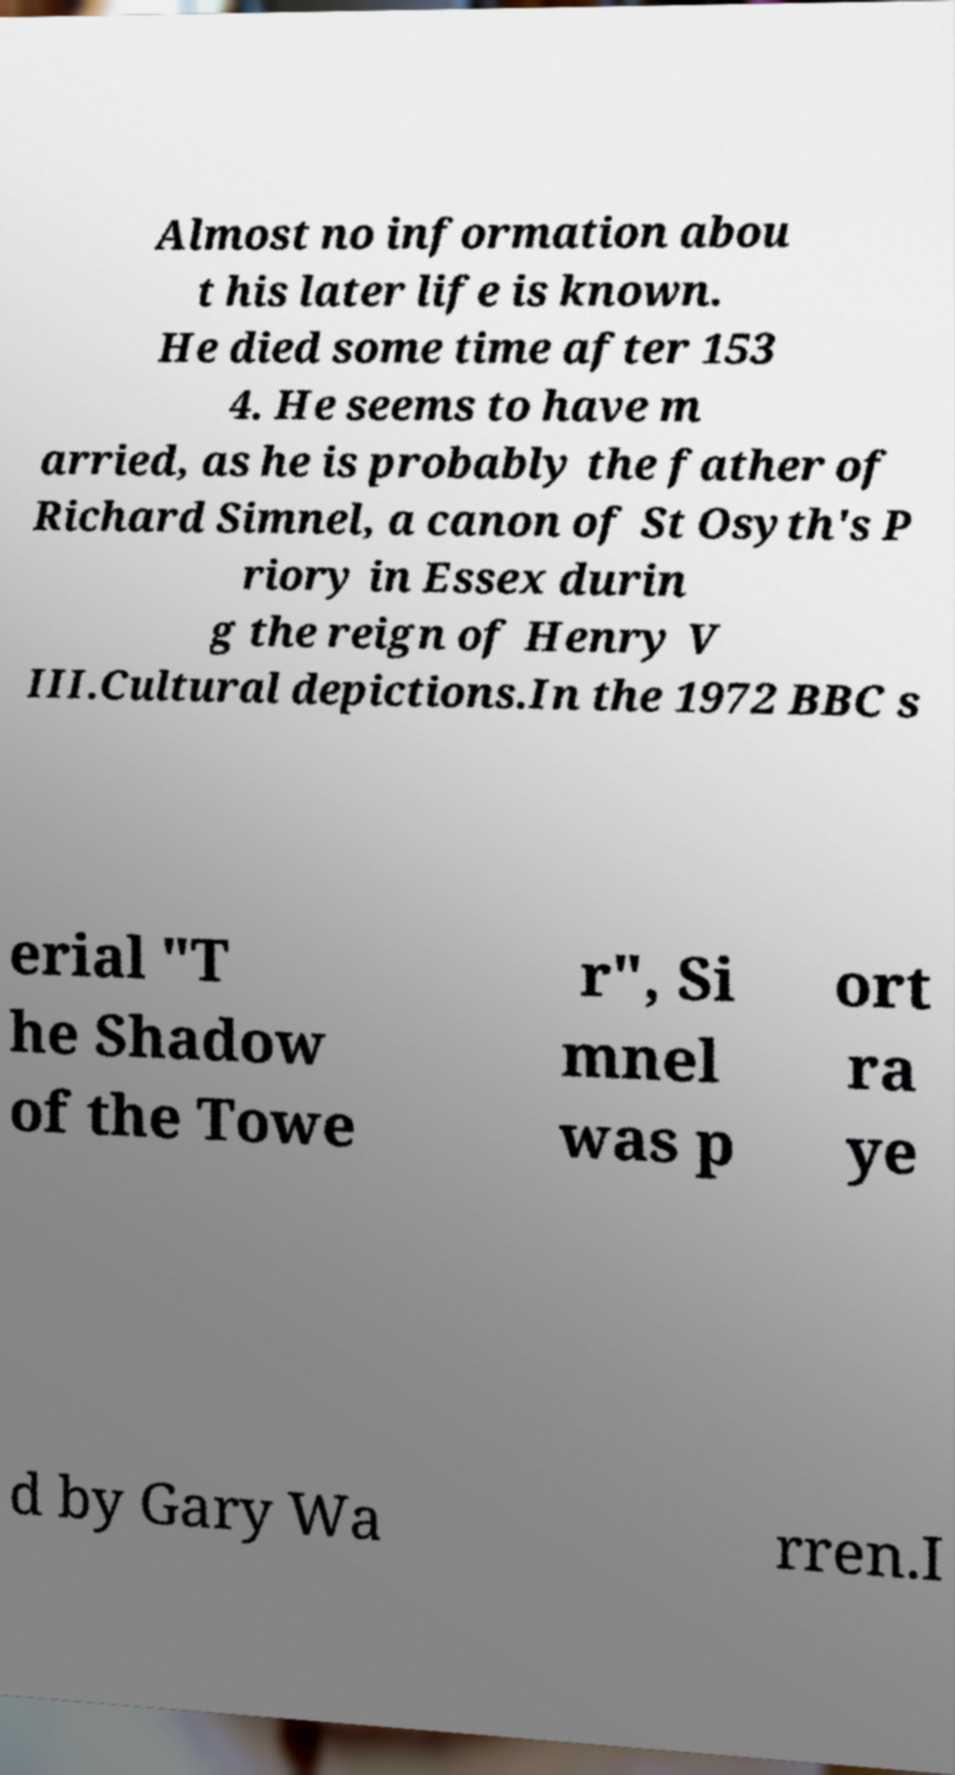Could you extract and type out the text from this image? Almost no information abou t his later life is known. He died some time after 153 4. He seems to have m arried, as he is probably the father of Richard Simnel, a canon of St Osyth's P riory in Essex durin g the reign of Henry V III.Cultural depictions.In the 1972 BBC s erial "T he Shadow of the Towe r", Si mnel was p ort ra ye d by Gary Wa rren.I 